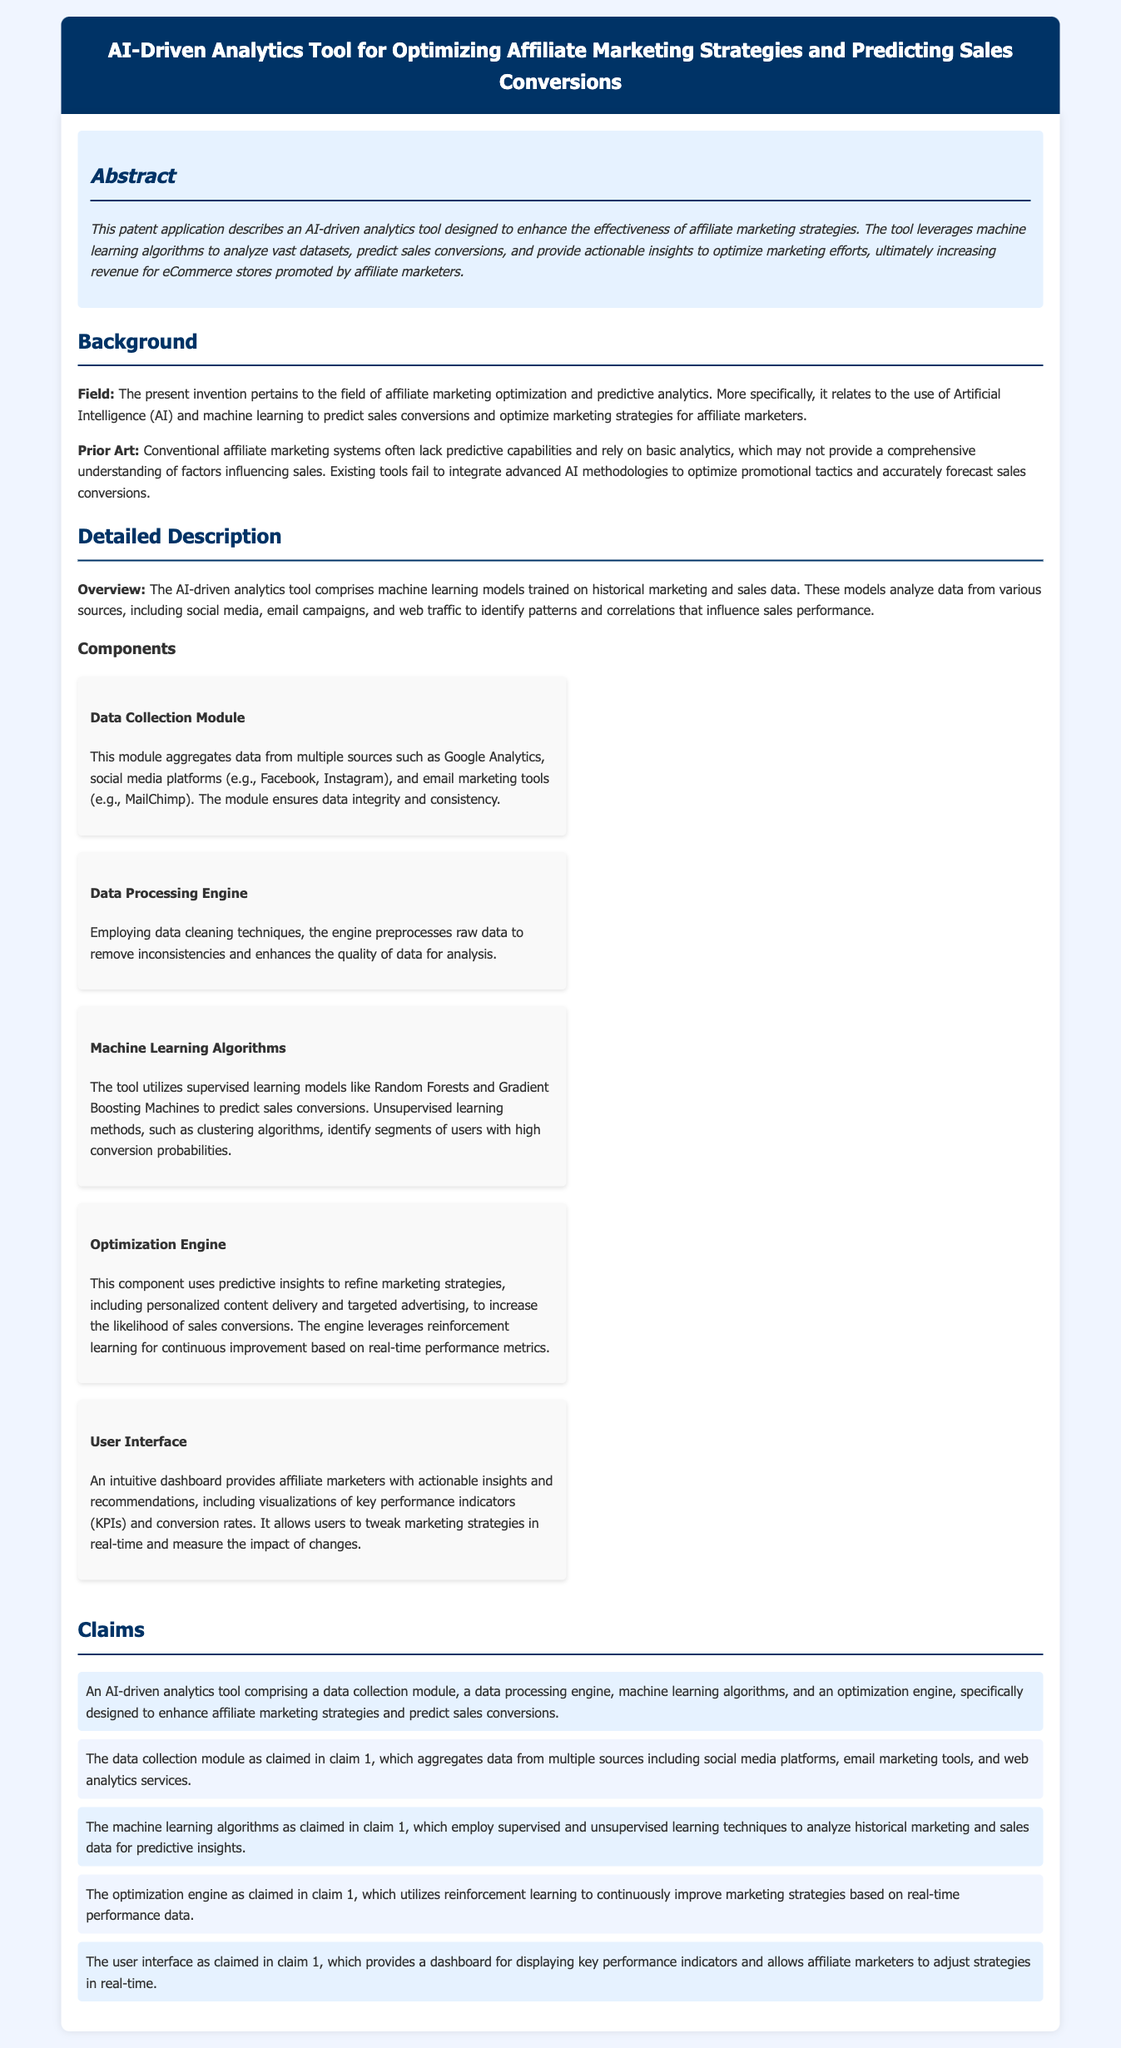What is the title of the patent application? The title is stated at the top of the document, summarizing the focus of the invention.
Answer: AI-Driven Analytics Tool for Optimizing Affiliate Marketing Strategies and Predicting Sales Conversions What is the primary purpose of the AI-driven analytics tool? The purpose is outlined in the abstract, detailing the tool's intended effect on marketing strategies and sales.
Answer: Enhance the effectiveness of affiliate marketing strategies Which algorithms does the tool utilize for predictions? The detailed description mentions specific algorithms used within the tool for making predictions.
Answer: Random Forests and Gradient Boosting Machines What does the data collection module aggregate data from? The claims section describes the sources of data that the data collection module uses.
Answer: Multiple sources including social media platforms, email marketing tools, and web analytics services How does the optimization engine improve marketing strategies? The detailed description explains the mechanism used by the optimization engine to refine strategies.
Answer: Uses predictive insights and reinforcement learning What is the main benefit for affiliate marketers using the user interface? The user interface section describes the insights and functionalities provided to users.
Answer: Provides actionable insights and recommendations What kind of learning techniques are employed in the machine learning algorithms? The detail about algorithms reveals the types of learning techniques applied within the tool.
Answer: Supervised and unsupervised learning techniques What is provided on the intuitive dashboard? The user interface section specifies what information and tools are available on the dashboard for users.
Answer: Visualizations of key performance indicators (KPIs) and conversion rates 